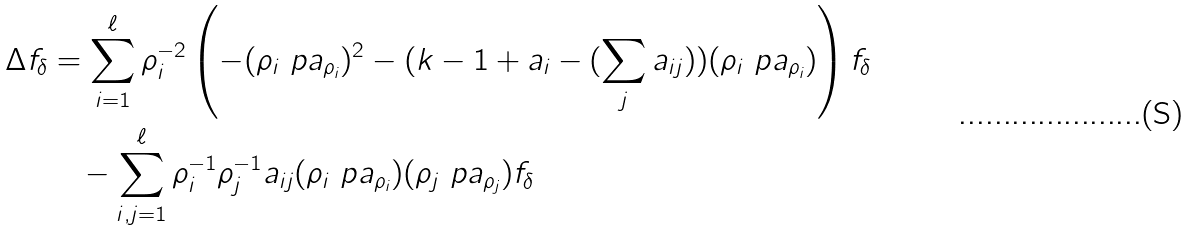<formula> <loc_0><loc_0><loc_500><loc_500>\Delta f _ { \delta } & = \sum _ { i = 1 } ^ { \ell } \rho _ { i } ^ { - 2 } \left ( - ( \rho _ { i } \ p a _ { \rho _ { i } } ) ^ { 2 } - ( k - 1 + a _ { i } - ( \sum _ { j } a _ { i j } ) ) ( \rho _ { i } \ p a _ { \rho _ { i } } ) \right ) f _ { \delta } \\ & \quad - \sum _ { i , j = 1 } ^ { \ell } \rho _ { i } ^ { - 1 } \rho _ { j } ^ { - 1 } a _ { i j } ( \rho _ { i } \ p a _ { \rho _ { i } } ) ( \rho _ { j } \ p a _ { \rho _ { j } } ) f _ { \delta }</formula> 